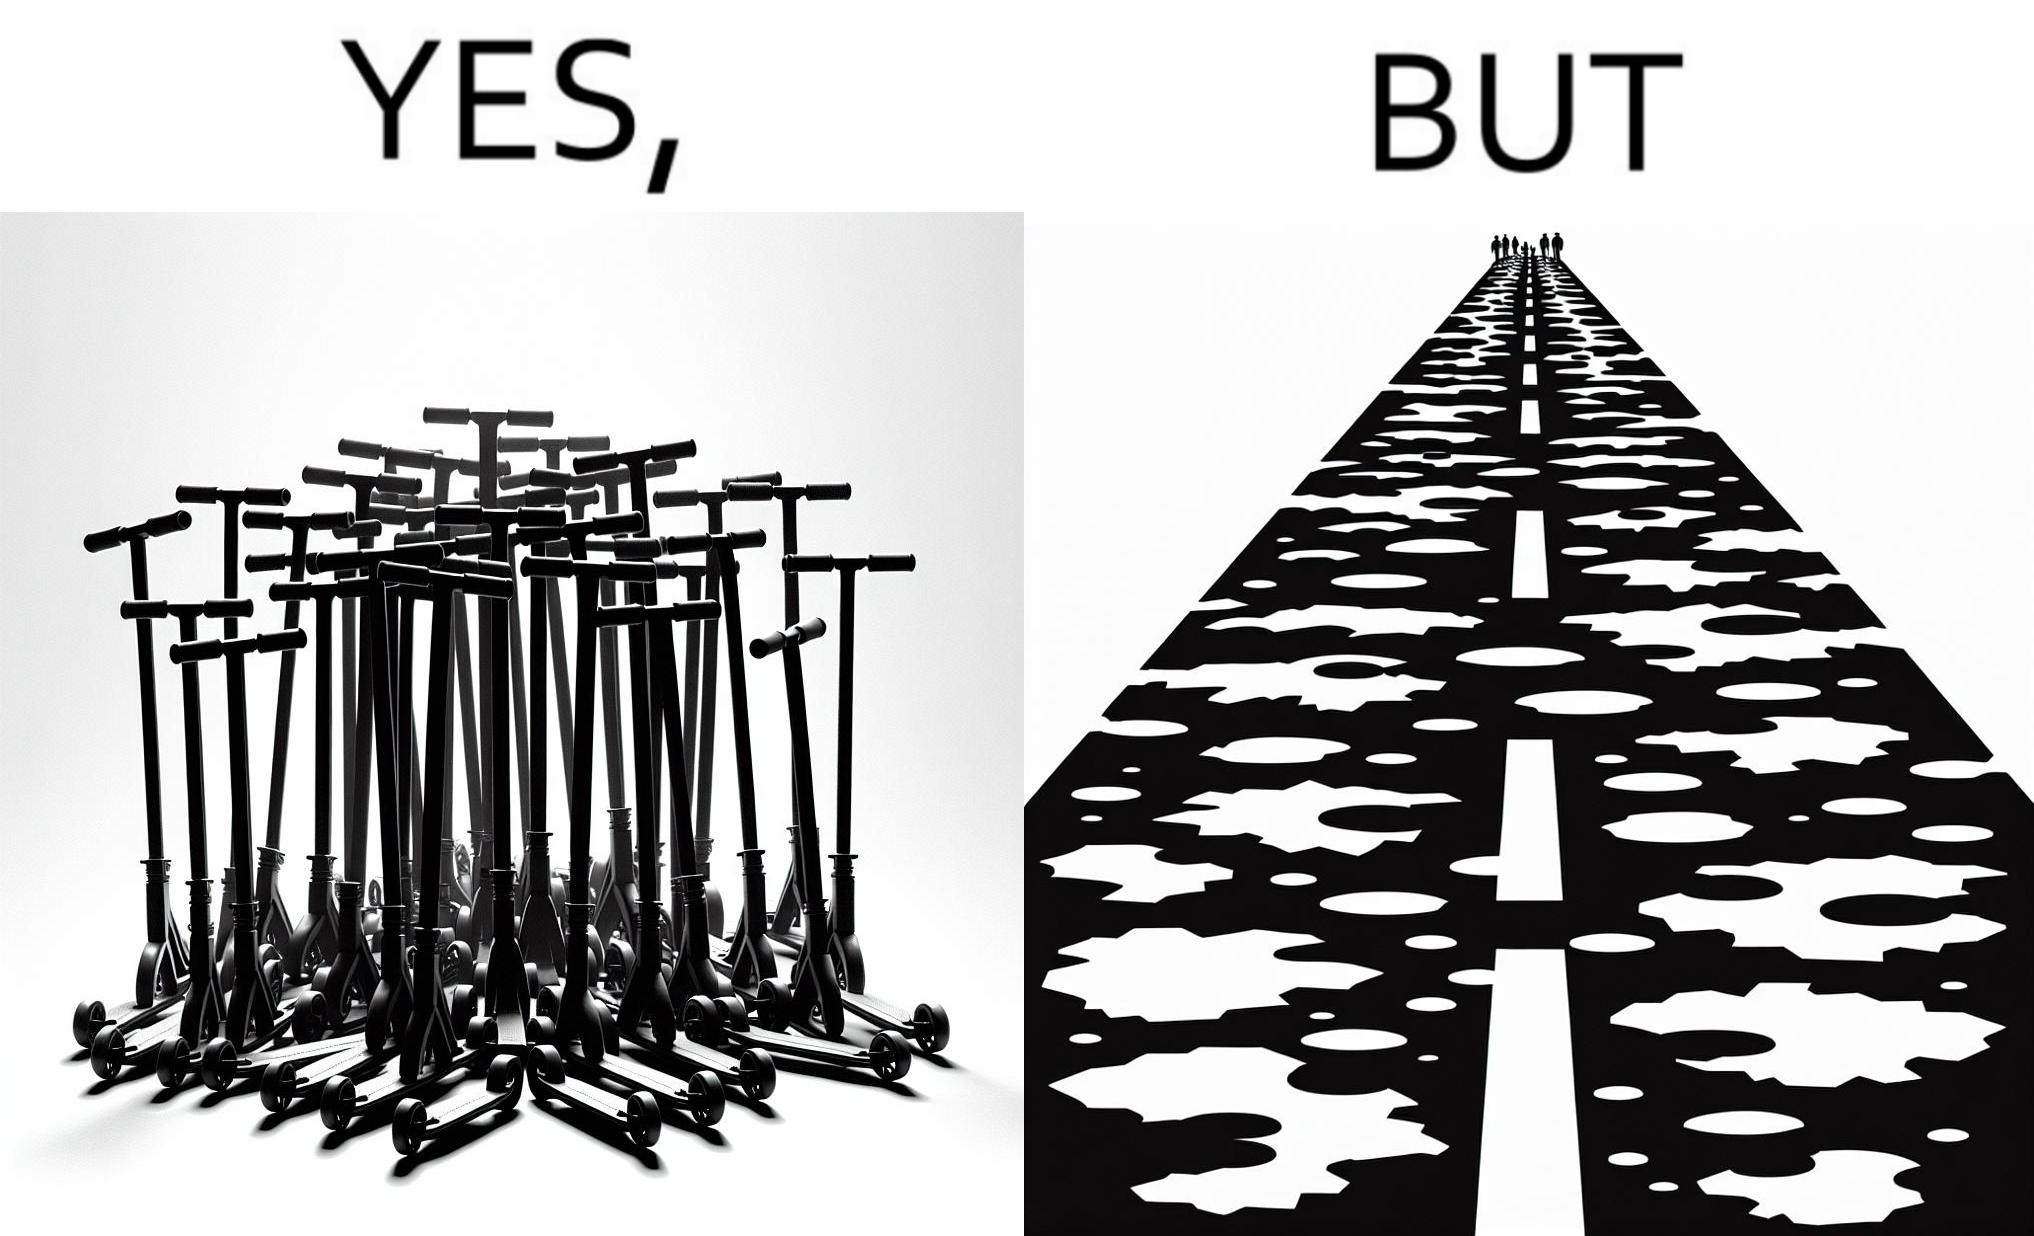What do you see in each half of this image? In the left part of the image: many skateboard scooters parked together In the right part of the image: a straight road with many potholes 